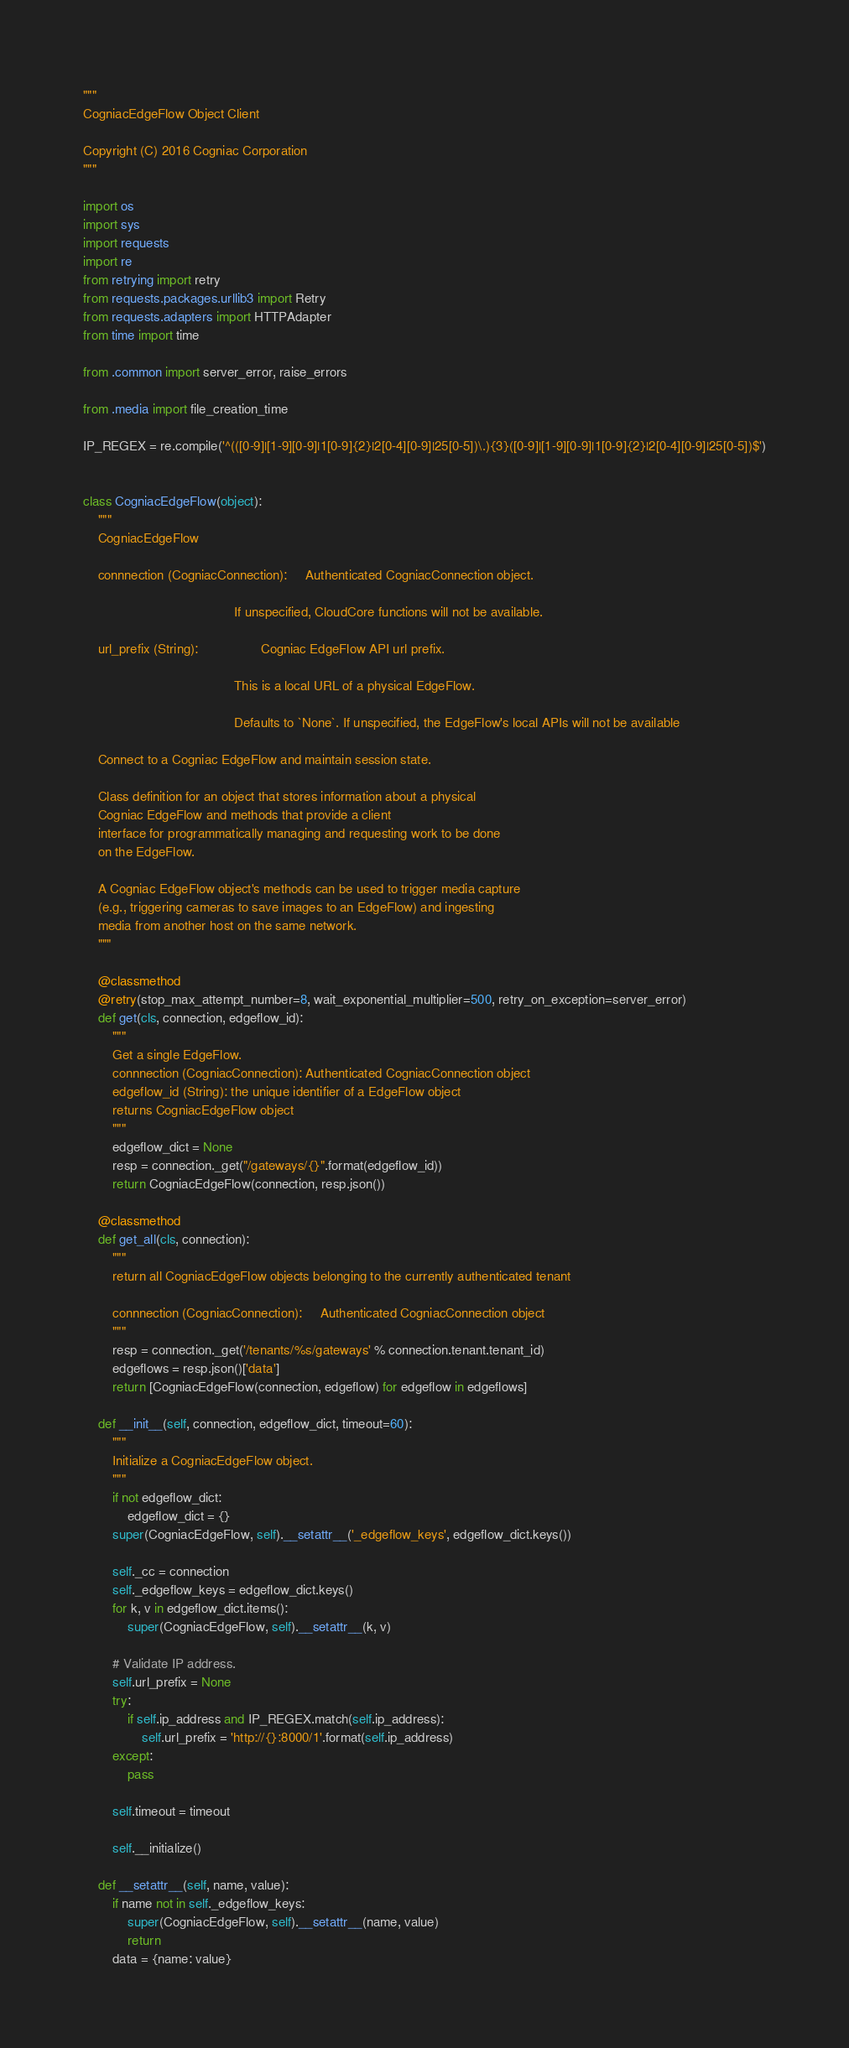<code> <loc_0><loc_0><loc_500><loc_500><_Python_>"""
CogniacEdgeFlow Object Client

Copyright (C) 2016 Cogniac Corporation
"""

import os
import sys
import requests
import re
from retrying import retry
from requests.packages.urllib3 import Retry
from requests.adapters import HTTPAdapter
from time import time

from .common import server_error, raise_errors

from .media import file_creation_time

IP_REGEX = re.compile('^(([0-9]|[1-9][0-9]|1[0-9]{2}|2[0-4][0-9]|25[0-5])\.){3}([0-9]|[1-9][0-9]|1[0-9]{2}|2[0-4][0-9]|25[0-5])$')


class CogniacEdgeFlow(object):
    """
    CogniacEdgeFlow

    connnection (CogniacConnection):     Authenticated CogniacConnection object.

                                         If unspecified, CloudCore functions will not be available.

    url_prefix (String):                 Cogniac EdgeFlow API url prefix.

                                         This is a local URL of a physical EdgeFlow.

                                         Defaults to `None`. If unspecified, the EdgeFlow's local APIs will not be available

    Connect to a Cogniac EdgeFlow and maintain session state.
    
    Class definition for an object that stores information about a physical
    Cogniac EdgeFlow and methods that provide a client
    interface for programmatically managing and requesting work to be done
    on the EdgeFlow.
    
    A Cogniac EdgeFlow object's methods can be used to trigger media capture
    (e.g., triggering cameras to save images to an EdgeFlow) and ingesting
    media from another host on the same network.
    """

    @classmethod
    @retry(stop_max_attempt_number=8, wait_exponential_multiplier=500, retry_on_exception=server_error)
    def get(cls, connection, edgeflow_id):
        """
        Get a single EdgeFlow.
        connnection (CogniacConnection): Authenticated CogniacConnection object
        edgeflow_id (String): the unique identifier of a EdgeFlow object
        returns CogniacEdgeFlow object
        """
        edgeflow_dict = None
        resp = connection._get("/gateways/{}".format(edgeflow_id))
        return CogniacEdgeFlow(connection, resp.json())

    @classmethod
    def get_all(cls, connection):
        """
        return all CogniacEdgeFlow objects belonging to the currently authenticated tenant

        connnection (CogniacConnection):     Authenticated CogniacConnection object
        """
        resp = connection._get('/tenants/%s/gateways' % connection.tenant.tenant_id)
        edgeflows = resp.json()['data']
        return [CogniacEdgeFlow(connection, edgeflow) for edgeflow in edgeflows]

    def __init__(self, connection, edgeflow_dict, timeout=60):
        """
        Initialize a CogniacEdgeFlow object.
        """
        if not edgeflow_dict:
            edgeflow_dict = {}
        super(CogniacEdgeFlow, self).__setattr__('_edgeflow_keys', edgeflow_dict.keys())

        self._cc = connection
        self._edgeflow_keys = edgeflow_dict.keys()
        for k, v in edgeflow_dict.items():
            super(CogniacEdgeFlow, self).__setattr__(k, v)

        # Validate IP address.
        self.url_prefix = None
        try:
            if self.ip_address and IP_REGEX.match(self.ip_address):
                self.url_prefix = 'http://{}:8000/1'.format(self.ip_address)
        except:
            pass

        self.timeout = timeout

        self.__initialize()

    def __setattr__(self, name, value):
        if name not in self._edgeflow_keys:
            super(CogniacEdgeFlow, self).__setattr__(name, value)
            return
        data = {name: value}</code> 